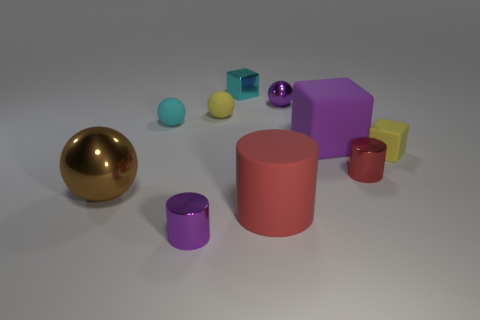How many large purple blocks are there?
Provide a short and direct response. 1. There is a big brown metal object; how many tiny cyan matte spheres are right of it?
Your response must be concise. 1. Does the cyan ball have the same material as the small red thing?
Keep it short and to the point. No. How many shiny spheres are to the right of the large cylinder and to the left of the cyan rubber sphere?
Your answer should be compact. 0. What number of other things are there of the same color as the large shiny ball?
Provide a succinct answer. 0. How many green things are either cylinders or matte cubes?
Your response must be concise. 0. The brown sphere has what size?
Provide a short and direct response. Large. How many shiny things are either red objects or big yellow blocks?
Give a very brief answer. 1. Are there fewer purple shiny cylinders than small yellow rubber things?
Offer a terse response. Yes. How many other objects are the same material as the tiny purple ball?
Keep it short and to the point. 4. 